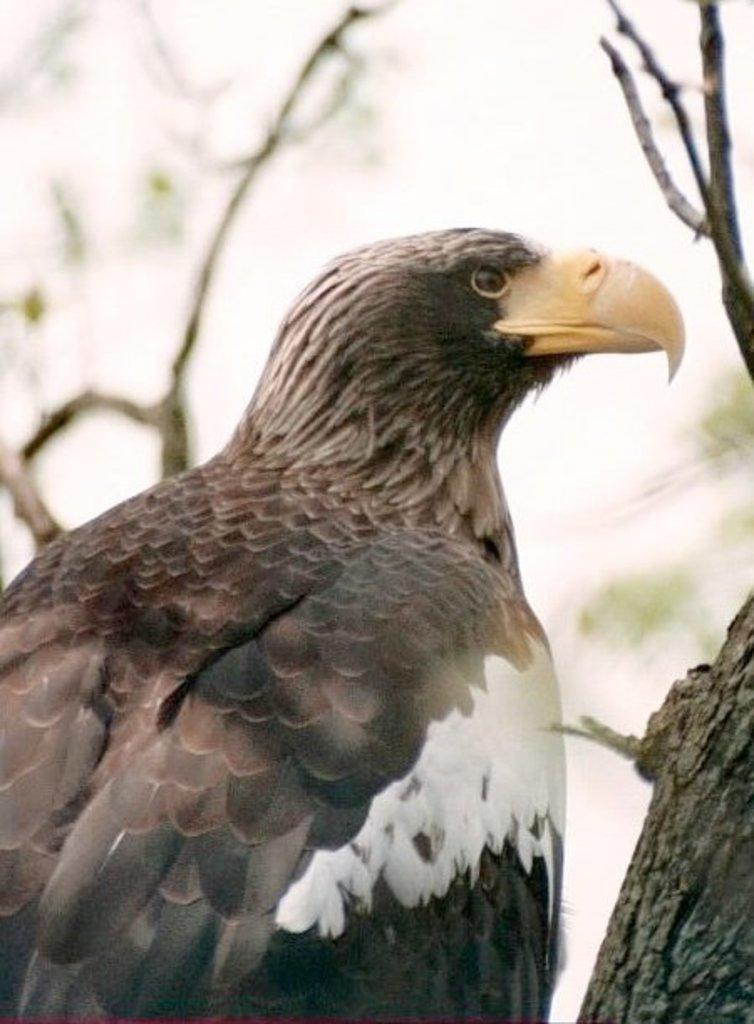What animal is featured in the image? There is an eagle in the image. What colors can be seen on the eagle? The eagle has black and white color. What is the color of the eagle's beak? The eagle's beak is yellow. What can be seen in the background of the image? There are branches in the background of the image. Can you tell me how many stamps are on the eagle's wings in the image? There are no stamps present on the eagle's wings in the image. What type of kite is the eagle holding in its talons in the image? There is no kite present in the image; the eagle is not holding anything in its talons. 